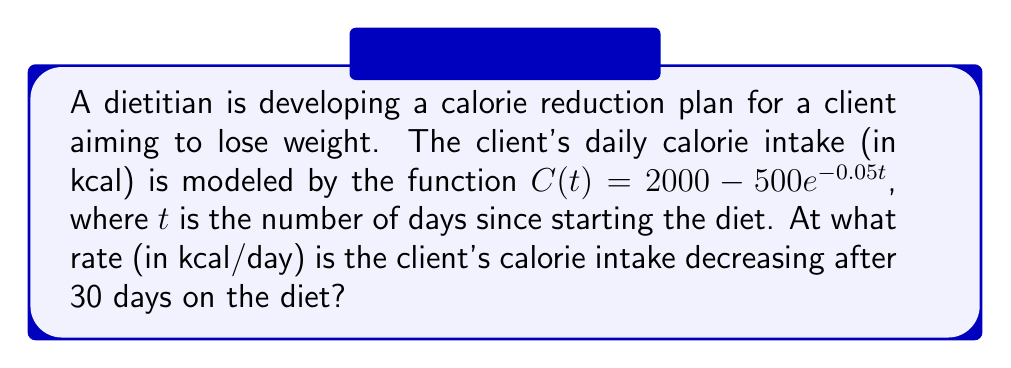Teach me how to tackle this problem. To solve this problem, we need to find the rate of change of the calorie intake function at $t = 30$ days. This can be done by taking the derivative of $C(t)$ and then evaluating it at $t = 30$.

Step 1: Find the derivative of $C(t)$
$$C(t) = 2000 - 500e^{-0.05t}$$
$$\frac{d}{dt}C(t) = 0 - 500 \cdot \frac{d}{dt}(e^{-0.05t})$$
$$\frac{d}{dt}C(t) = -500 \cdot (-0.05e^{-0.05t})$$
$$\frac{d}{dt}C(t) = 25e^{-0.05t}$$

Step 2: Evaluate the derivative at $t = 30$
$$\frac{d}{dt}C(30) = 25e^{-0.05(30)}$$
$$\frac{d}{dt}C(30) = 25e^{-1.5}$$
$$\frac{d}{dt}C(30) \approx 5.57 \text{ kcal/day}$$

The positive value indicates that the rate of change is positive, meaning the calorie intake is actually increasing. However, the question asks for the rate at which the calorie intake is decreasing, so we need to negate this value.

Step 3: Negate the result
Rate of decrease = $-5.57 \text{ kcal/day}$

Therefore, after 30 days on the diet, the client's calorie intake is decreasing at a rate of approximately 5.57 kcal per day.
Answer: $-5.57 \text{ kcal/day}$ 